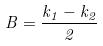<formula> <loc_0><loc_0><loc_500><loc_500>B = \frac { k _ { 1 } - k _ { 2 } } { 2 }</formula> 